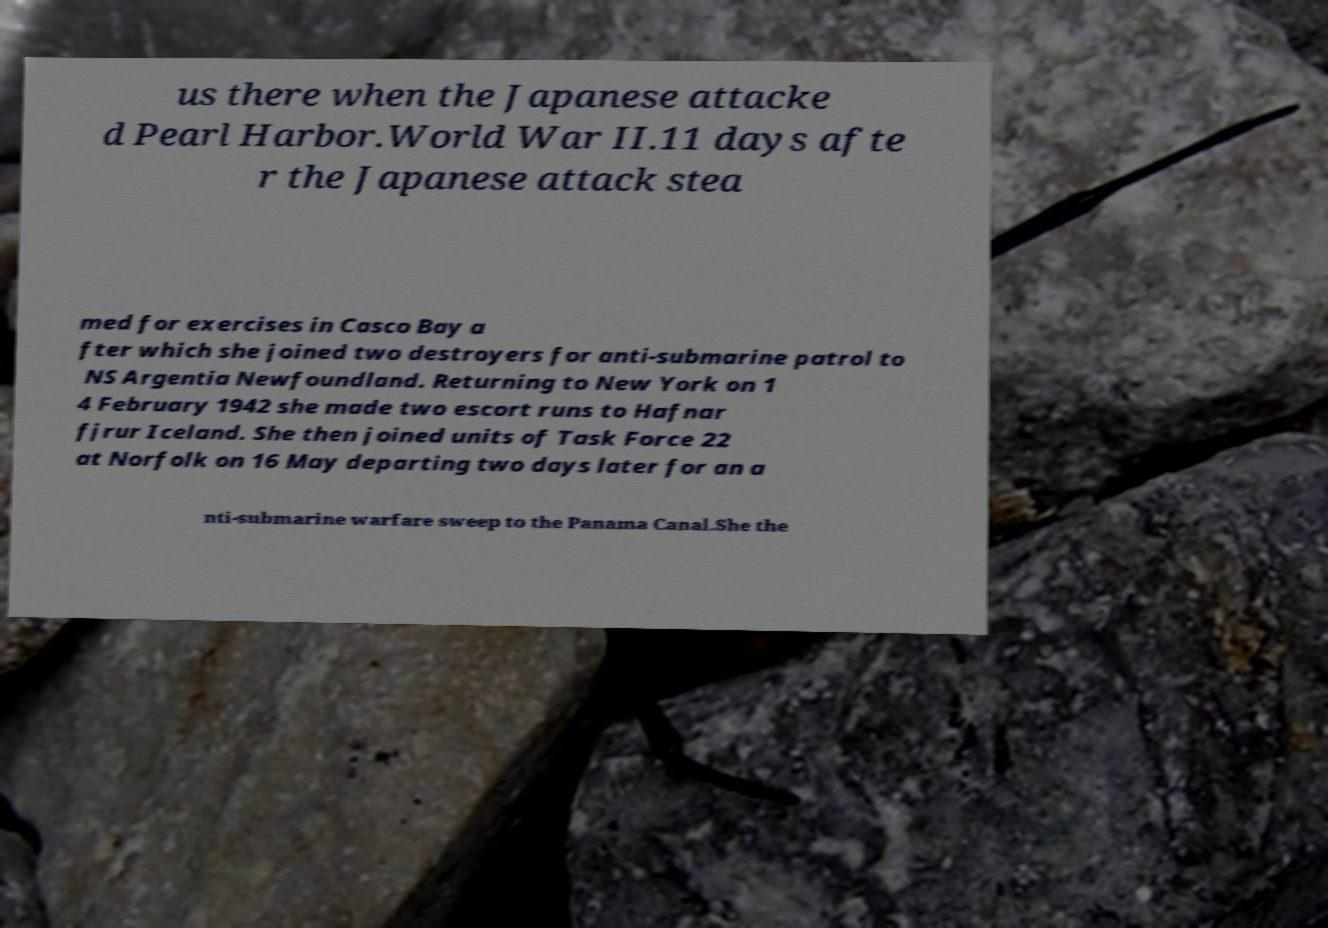Please identify and transcribe the text found in this image. us there when the Japanese attacke d Pearl Harbor.World War II.11 days afte r the Japanese attack stea med for exercises in Casco Bay a fter which she joined two destroyers for anti-submarine patrol to NS Argentia Newfoundland. Returning to New York on 1 4 February 1942 she made two escort runs to Hafnar fjrur Iceland. She then joined units of Task Force 22 at Norfolk on 16 May departing two days later for an a nti-submarine warfare sweep to the Panama Canal.She the 